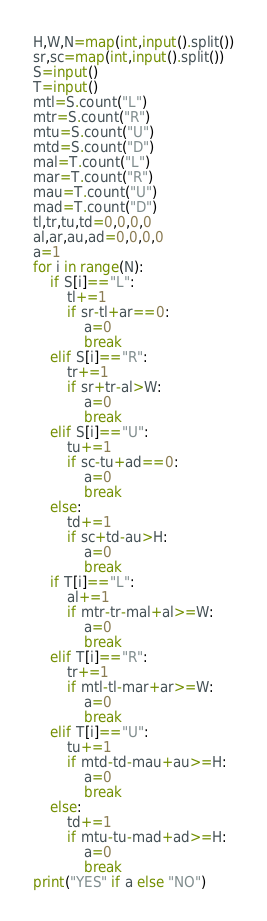Convert code to text. <code><loc_0><loc_0><loc_500><loc_500><_Python_>H,W,N=map(int,input().split())
sr,sc=map(int,input().split())
S=input()
T=input()
mtl=S.count("L")
mtr=S.count("R")
mtu=S.count("U")
mtd=S.count("D")
mal=T.count("L")
mar=T.count("R")
mau=T.count("U")
mad=T.count("D")
tl,tr,tu,td=0,0,0,0
al,ar,au,ad=0,0,0,0
a=1
for i in range(N):
    if S[i]=="L":
        tl+=1
        if sr-tl+ar==0:
            a=0
            break
    elif S[i]=="R":
        tr+=1
        if sr+tr-al>W:
            a=0
            break
    elif S[i]=="U":
        tu+=1
        if sc-tu+ad==0:
            a=0
            break
    else:
        td+=1
        if sc+td-au>H:
            a=0
            break
    if T[i]=="L":
        al+=1
        if mtr-tr-mal+al>=W:
            a=0
            break
    elif T[i]=="R":
        tr+=1
        if mtl-tl-mar+ar>=W:
            a=0
            break
    elif T[i]=="U":
        tu+=1
        if mtd-td-mau+au>=H:
            a=0
            break
    else:
        td+=1
        if mtu-tu-mad+ad>=H:
            a=0
            break
print("YES" if a else "NO")</code> 